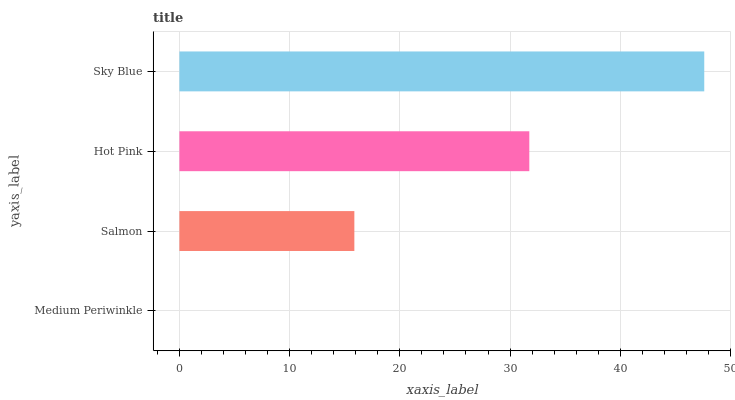Is Medium Periwinkle the minimum?
Answer yes or no. Yes. Is Sky Blue the maximum?
Answer yes or no. Yes. Is Salmon the minimum?
Answer yes or no. No. Is Salmon the maximum?
Answer yes or no. No. Is Salmon greater than Medium Periwinkle?
Answer yes or no. Yes. Is Medium Periwinkle less than Salmon?
Answer yes or no. Yes. Is Medium Periwinkle greater than Salmon?
Answer yes or no. No. Is Salmon less than Medium Periwinkle?
Answer yes or no. No. Is Hot Pink the high median?
Answer yes or no. Yes. Is Salmon the low median?
Answer yes or no. Yes. Is Salmon the high median?
Answer yes or no. No. Is Medium Periwinkle the low median?
Answer yes or no. No. 